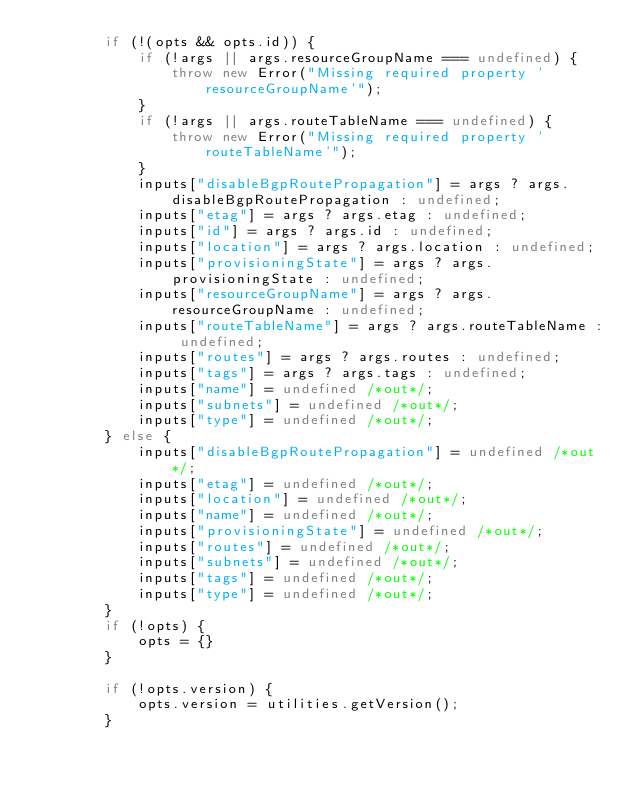<code> <loc_0><loc_0><loc_500><loc_500><_TypeScript_>        if (!(opts && opts.id)) {
            if (!args || args.resourceGroupName === undefined) {
                throw new Error("Missing required property 'resourceGroupName'");
            }
            if (!args || args.routeTableName === undefined) {
                throw new Error("Missing required property 'routeTableName'");
            }
            inputs["disableBgpRoutePropagation"] = args ? args.disableBgpRoutePropagation : undefined;
            inputs["etag"] = args ? args.etag : undefined;
            inputs["id"] = args ? args.id : undefined;
            inputs["location"] = args ? args.location : undefined;
            inputs["provisioningState"] = args ? args.provisioningState : undefined;
            inputs["resourceGroupName"] = args ? args.resourceGroupName : undefined;
            inputs["routeTableName"] = args ? args.routeTableName : undefined;
            inputs["routes"] = args ? args.routes : undefined;
            inputs["tags"] = args ? args.tags : undefined;
            inputs["name"] = undefined /*out*/;
            inputs["subnets"] = undefined /*out*/;
            inputs["type"] = undefined /*out*/;
        } else {
            inputs["disableBgpRoutePropagation"] = undefined /*out*/;
            inputs["etag"] = undefined /*out*/;
            inputs["location"] = undefined /*out*/;
            inputs["name"] = undefined /*out*/;
            inputs["provisioningState"] = undefined /*out*/;
            inputs["routes"] = undefined /*out*/;
            inputs["subnets"] = undefined /*out*/;
            inputs["tags"] = undefined /*out*/;
            inputs["type"] = undefined /*out*/;
        }
        if (!opts) {
            opts = {}
        }

        if (!opts.version) {
            opts.version = utilities.getVersion();
        }</code> 